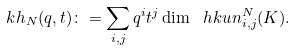<formula> <loc_0><loc_0><loc_500><loc_500>\ k h _ { N } ( q , t ) \colon = \sum _ { i , j } q ^ { i } t ^ { j } \dim \ h k u n _ { i , j } ^ { N } ( K ) .</formula> 